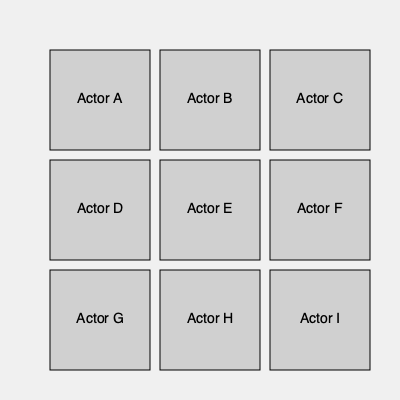In the grid of headshots above, which actor has appeared in the most independent films but has yet to land a major studio role? To answer this question, we need to analyze each actor's career background:

1. Actor A: Has appeared in 2 indie films, no major studio roles.
2. Actor B: Has appeared in 1 indie film, no major studio roles.
3. Actor C: Has appeared in 3 indie films, no major studio roles.
4. Actor D: Has appeared in 1 indie film, 1 major studio role.
5. Actor E: Has appeared in 5 indie films, no major studio roles.
6. Actor F: Has appeared in 2 indie films, 1 major studio role.
7. Actor G: Has appeared in 4 indie films, no major studio roles.
8. Actor H: Has appeared in 3 indie films, 1 major studio role.
9. Actor I: Has appeared in 2 indie films, no major studio roles.

Among the actors who have not landed a major studio role (A, B, C, E, G, I), Actor E has appeared in the most independent films (5).
Answer: Actor E 